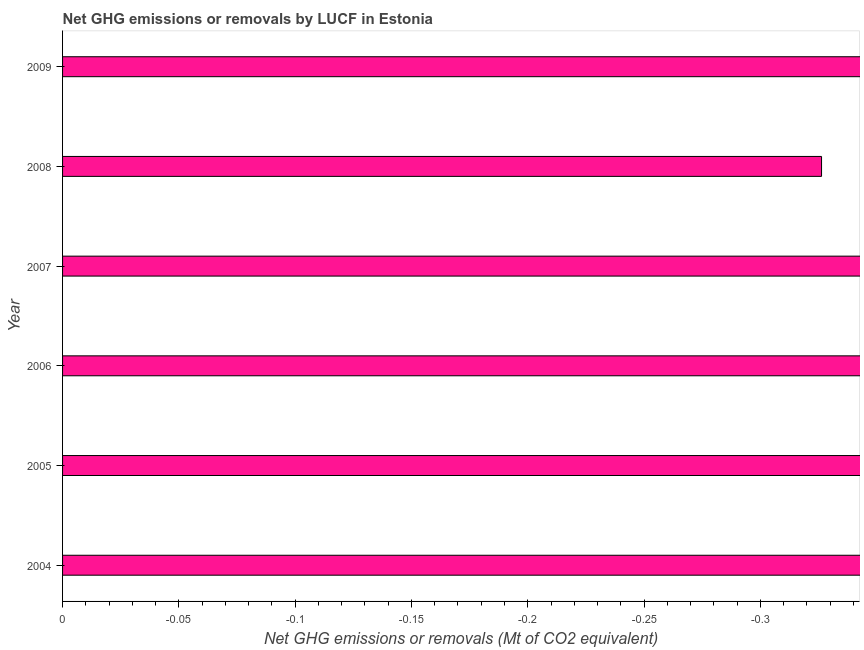Does the graph contain any zero values?
Your response must be concise. Yes. What is the title of the graph?
Make the answer very short. Net GHG emissions or removals by LUCF in Estonia. What is the label or title of the X-axis?
Give a very brief answer. Net GHG emissions or removals (Mt of CO2 equivalent). Across all years, what is the minimum ghg net emissions or removals?
Your answer should be compact. 0. What is the sum of the ghg net emissions or removals?
Provide a succinct answer. 0. What is the average ghg net emissions or removals per year?
Keep it short and to the point. 0. What is the median ghg net emissions or removals?
Make the answer very short. 0. In how many years, is the ghg net emissions or removals greater than -0.06 Mt?
Make the answer very short. 0. Are all the bars in the graph horizontal?
Make the answer very short. Yes. How many years are there in the graph?
Provide a succinct answer. 6. What is the difference between two consecutive major ticks on the X-axis?
Make the answer very short. 0.05. What is the Net GHG emissions or removals (Mt of CO2 equivalent) in 2004?
Your answer should be very brief. 0. What is the Net GHG emissions or removals (Mt of CO2 equivalent) in 2005?
Your answer should be very brief. 0. What is the Net GHG emissions or removals (Mt of CO2 equivalent) in 2007?
Provide a short and direct response. 0. What is the Net GHG emissions or removals (Mt of CO2 equivalent) of 2008?
Your response must be concise. 0. 